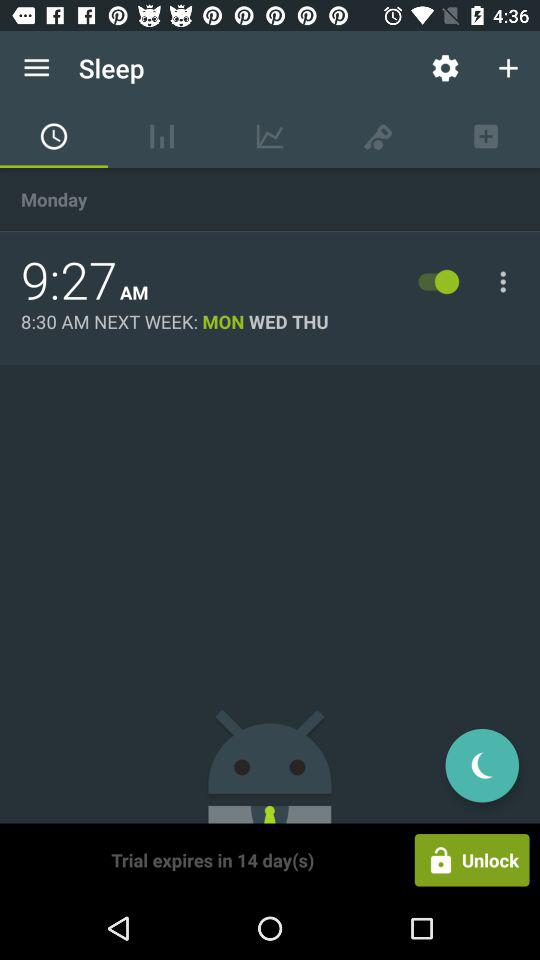What time is the sleep alarm set for? The alarm is set for 9:27 AM. 